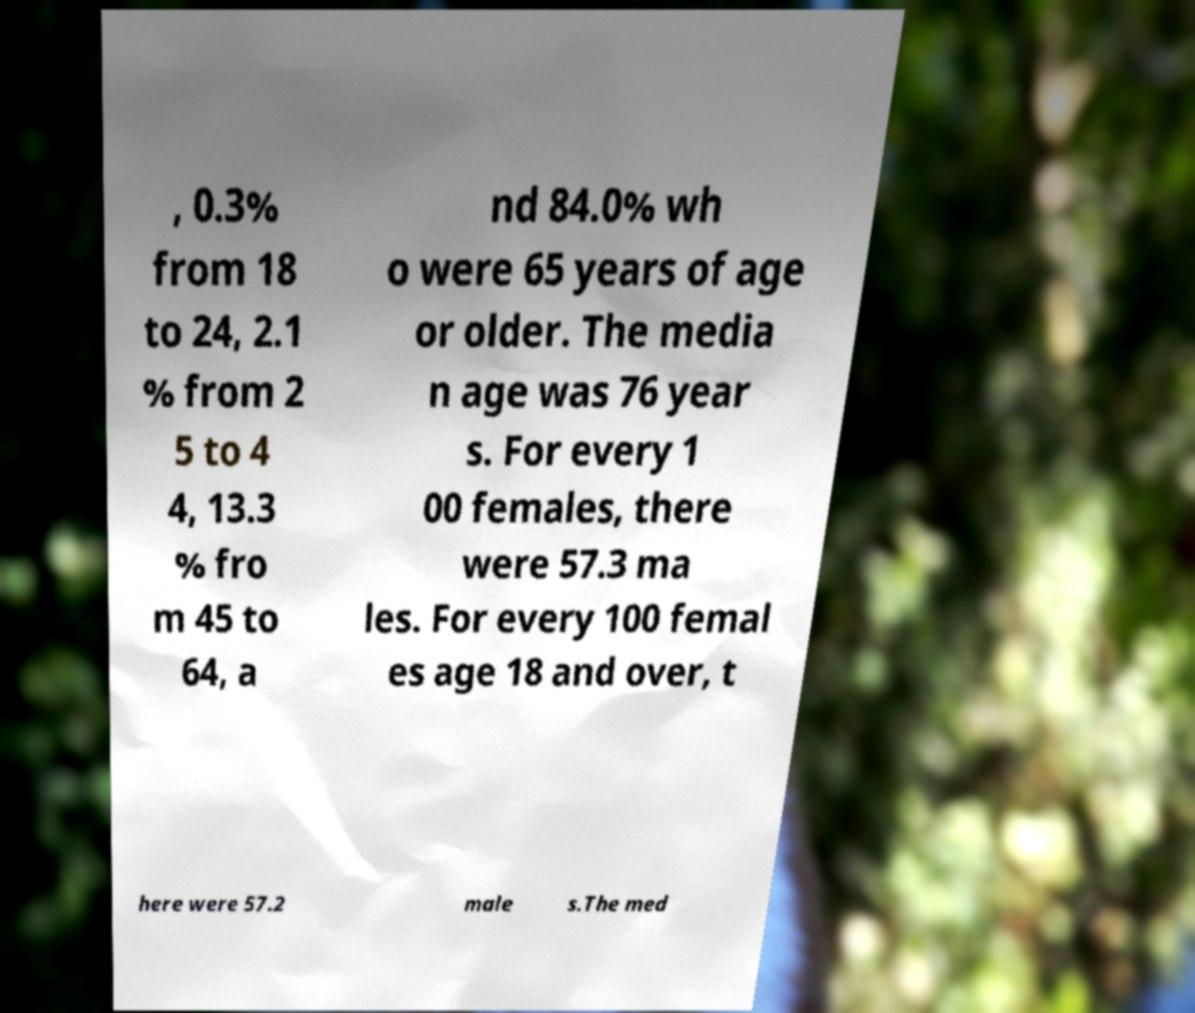For documentation purposes, I need the text within this image transcribed. Could you provide that? , 0.3% from 18 to 24, 2.1 % from 2 5 to 4 4, 13.3 % fro m 45 to 64, a nd 84.0% wh o were 65 years of age or older. The media n age was 76 year s. For every 1 00 females, there were 57.3 ma les. For every 100 femal es age 18 and over, t here were 57.2 male s.The med 